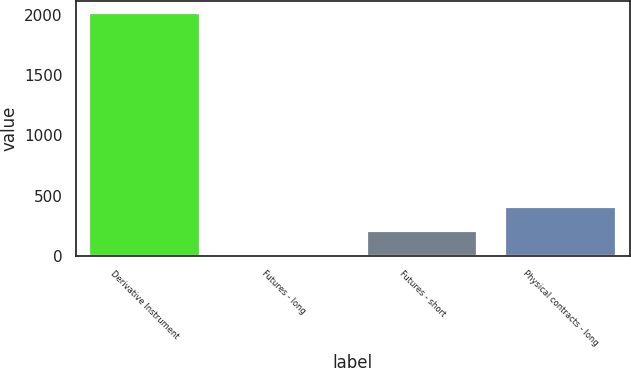Convert chart. <chart><loc_0><loc_0><loc_500><loc_500><bar_chart><fcel>Derivative Instrument<fcel>Futures - long<fcel>Futures - short<fcel>Physical contracts - long<nl><fcel>2014<fcel>5<fcel>205.9<fcel>406.8<nl></chart> 